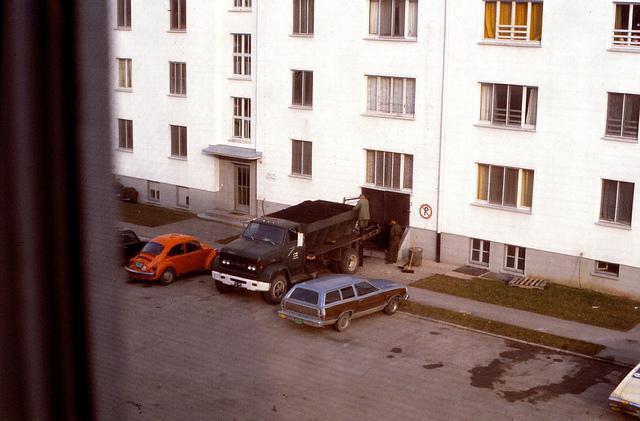Why is the truck backed up to the building?
From the following four choices, select the correct answer to address the question.
Options: Loading, robbery, blocking door, sales. Loading. 